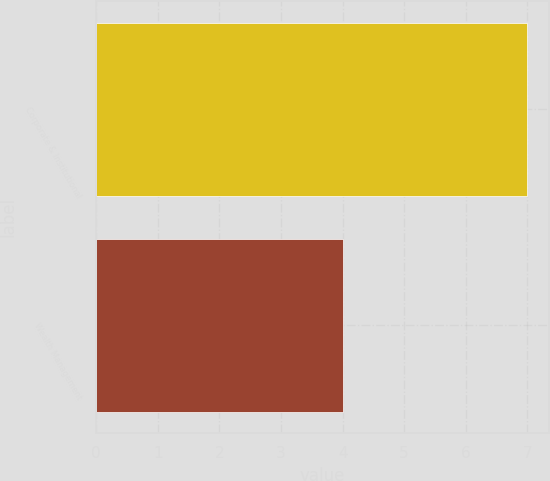Convert chart to OTSL. <chart><loc_0><loc_0><loc_500><loc_500><bar_chart><fcel>Corporate & Institutional<fcel>Wealth Management<nl><fcel>7<fcel>4<nl></chart> 